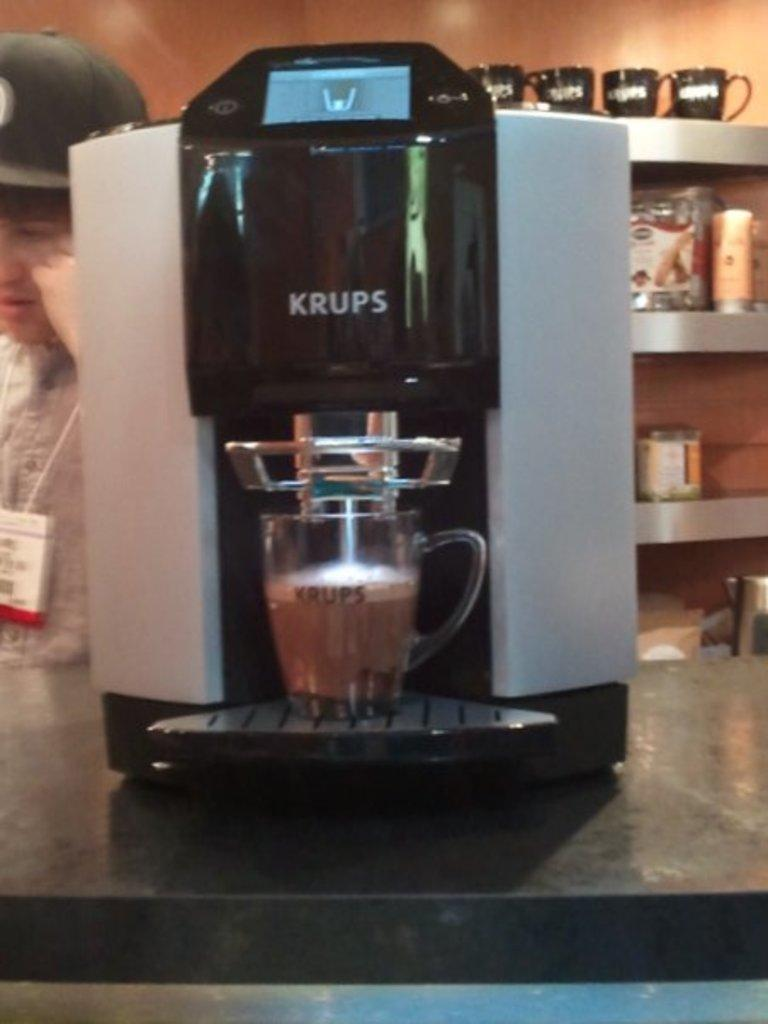What appliance is visible in the image? There is a coffee maker in the image. What might be used to hold a beverage in the image? There is a cup in the image. Can you describe the object on the left side of the image? There is a white object on the left side of the image. What type of storage is present in the image? There are shelves with cups and other objects in the image. What type of screw can be seen holding the plantation in the image? There is no screw or plantation present in the image. 